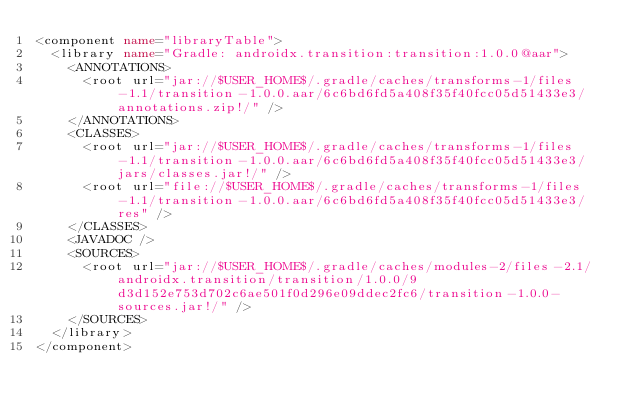<code> <loc_0><loc_0><loc_500><loc_500><_XML_><component name="libraryTable">
  <library name="Gradle: androidx.transition:transition:1.0.0@aar">
    <ANNOTATIONS>
      <root url="jar://$USER_HOME$/.gradle/caches/transforms-1/files-1.1/transition-1.0.0.aar/6c6bd6fd5a408f35f40fcc05d51433e3/annotations.zip!/" />
    </ANNOTATIONS>
    <CLASSES>
      <root url="jar://$USER_HOME$/.gradle/caches/transforms-1/files-1.1/transition-1.0.0.aar/6c6bd6fd5a408f35f40fcc05d51433e3/jars/classes.jar!/" />
      <root url="file://$USER_HOME$/.gradle/caches/transforms-1/files-1.1/transition-1.0.0.aar/6c6bd6fd5a408f35f40fcc05d51433e3/res" />
    </CLASSES>
    <JAVADOC />
    <SOURCES>
      <root url="jar://$USER_HOME$/.gradle/caches/modules-2/files-2.1/androidx.transition/transition/1.0.0/9d3d152e753d702c6ae501f0d296e09ddec2fc6/transition-1.0.0-sources.jar!/" />
    </SOURCES>
  </library>
</component></code> 